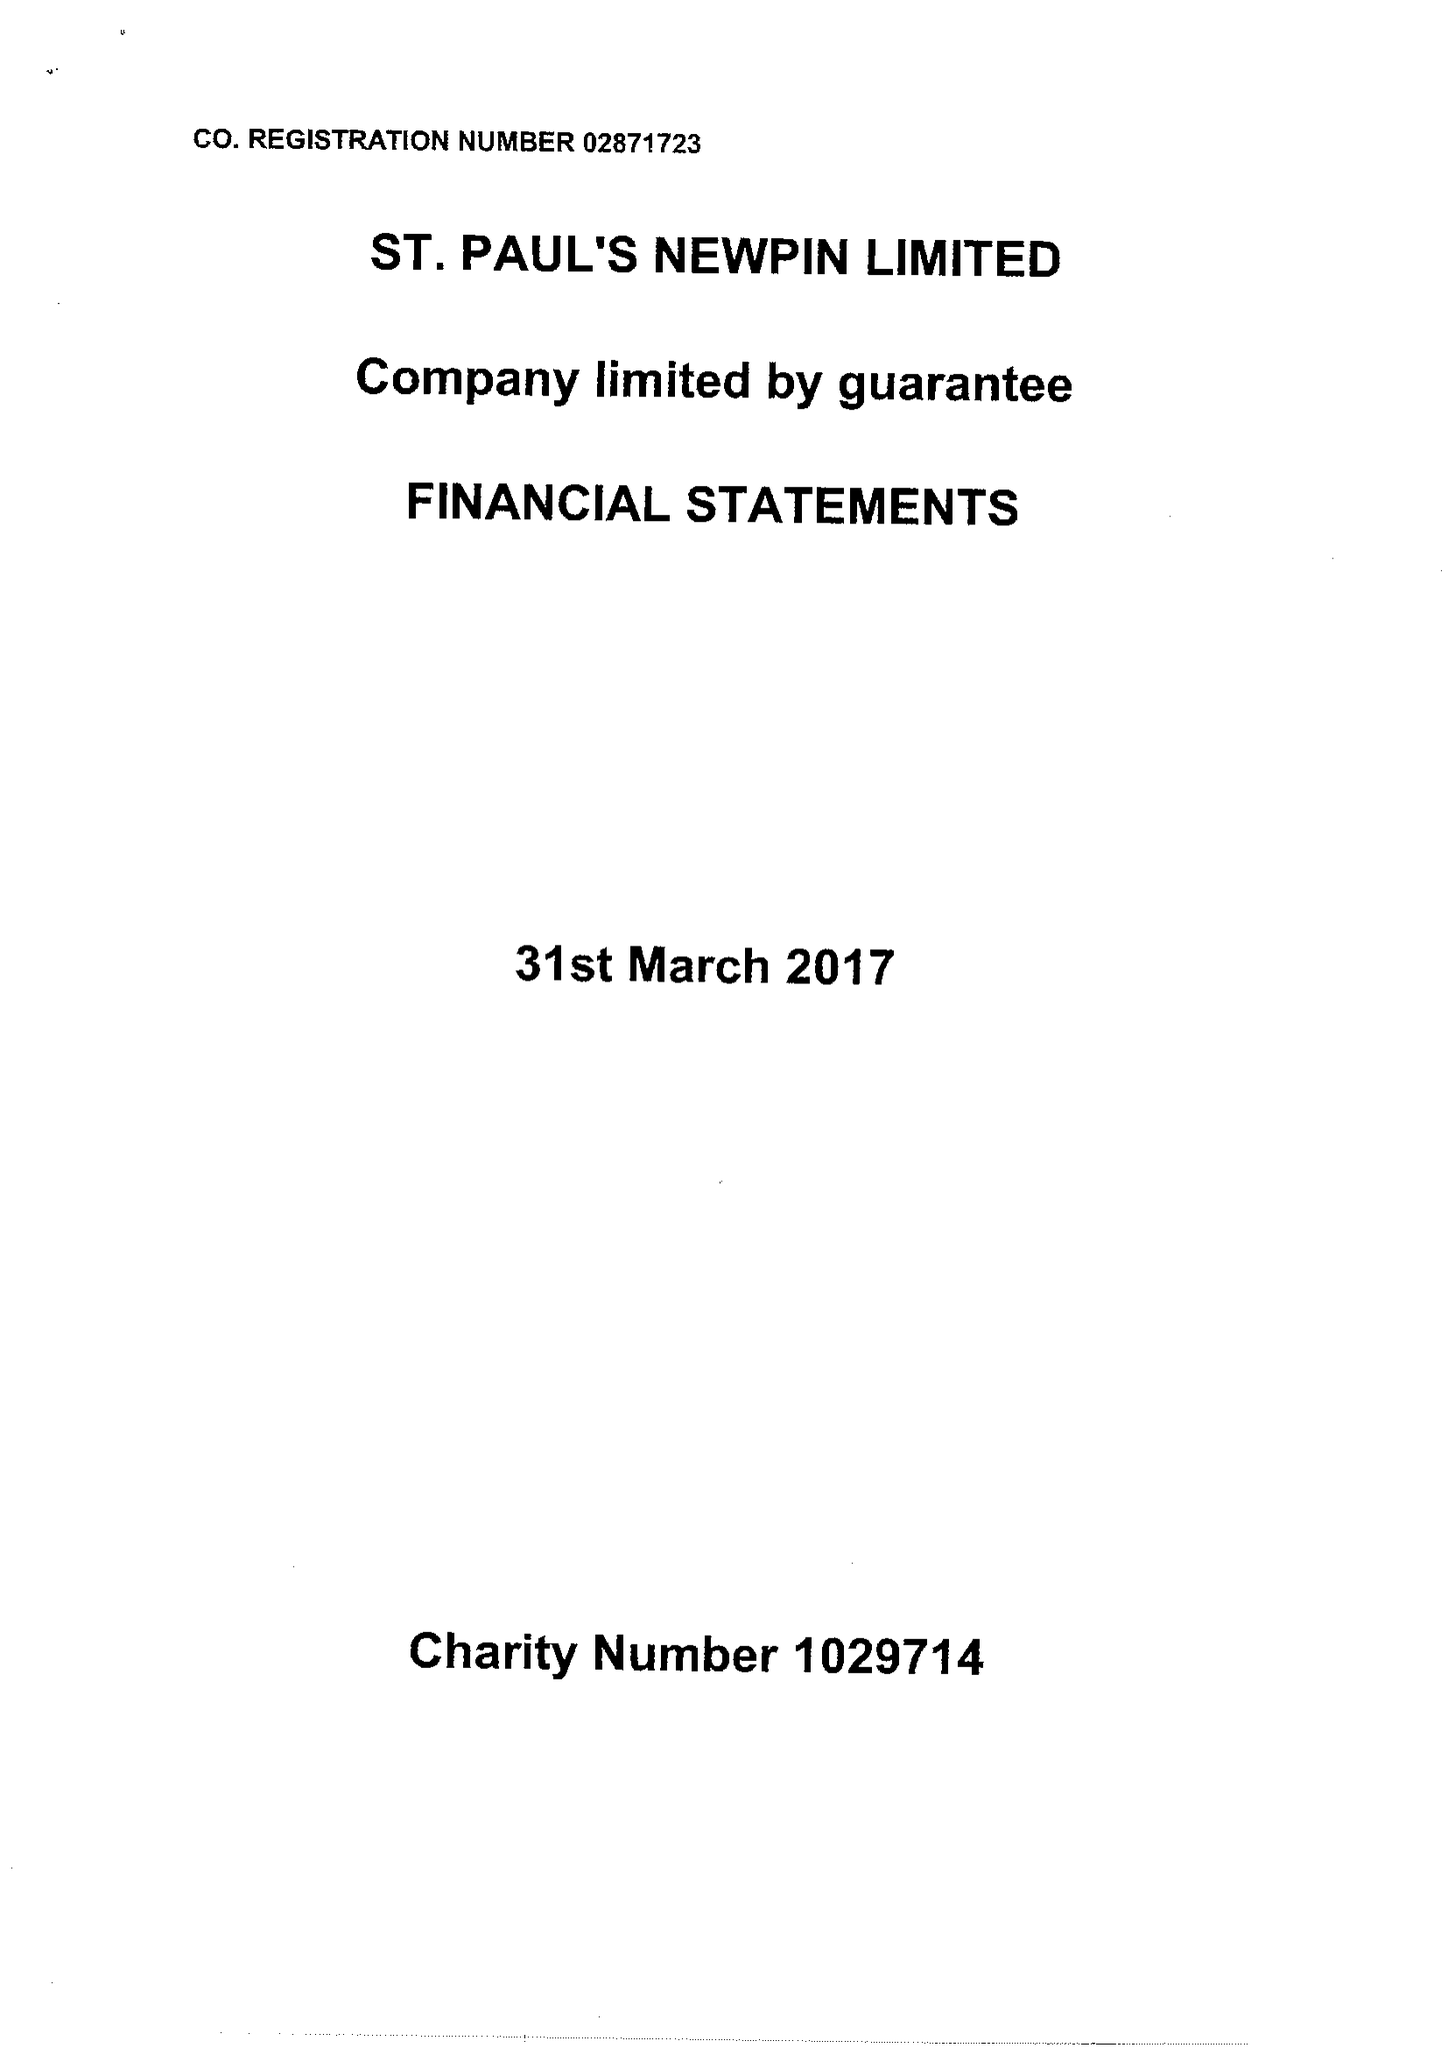What is the value for the spending_annually_in_british_pounds?
Answer the question using a single word or phrase. 106594.00 